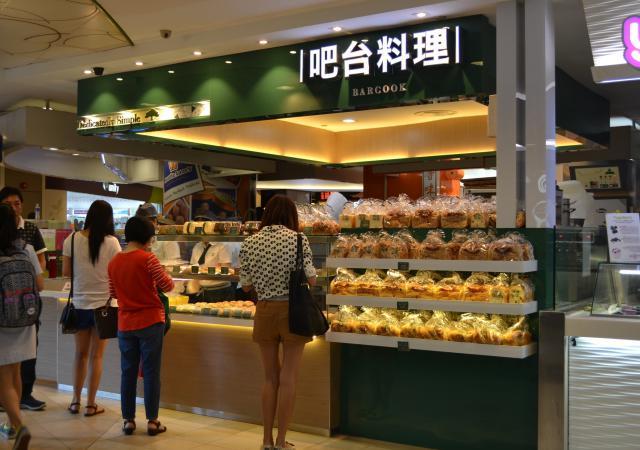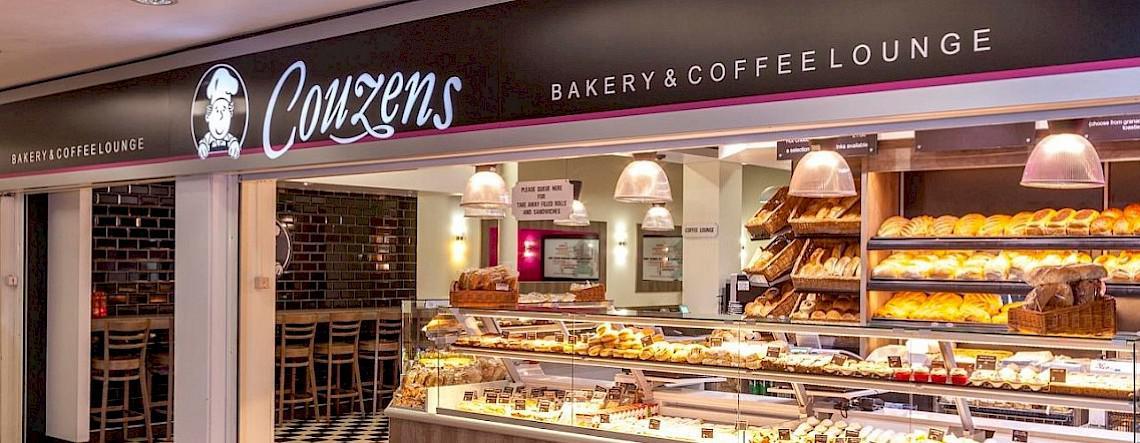The first image is the image on the left, the second image is the image on the right. Assess this claim about the two images: "At least one female with back to the camera is at a service counter in one image.". Correct or not? Answer yes or no. Yes. The first image is the image on the left, the second image is the image on the right. Evaluate the accuracy of this statement regarding the images: "People stand at the counter waiting for service in the image on the left.". Is it true? Answer yes or no. Yes. 